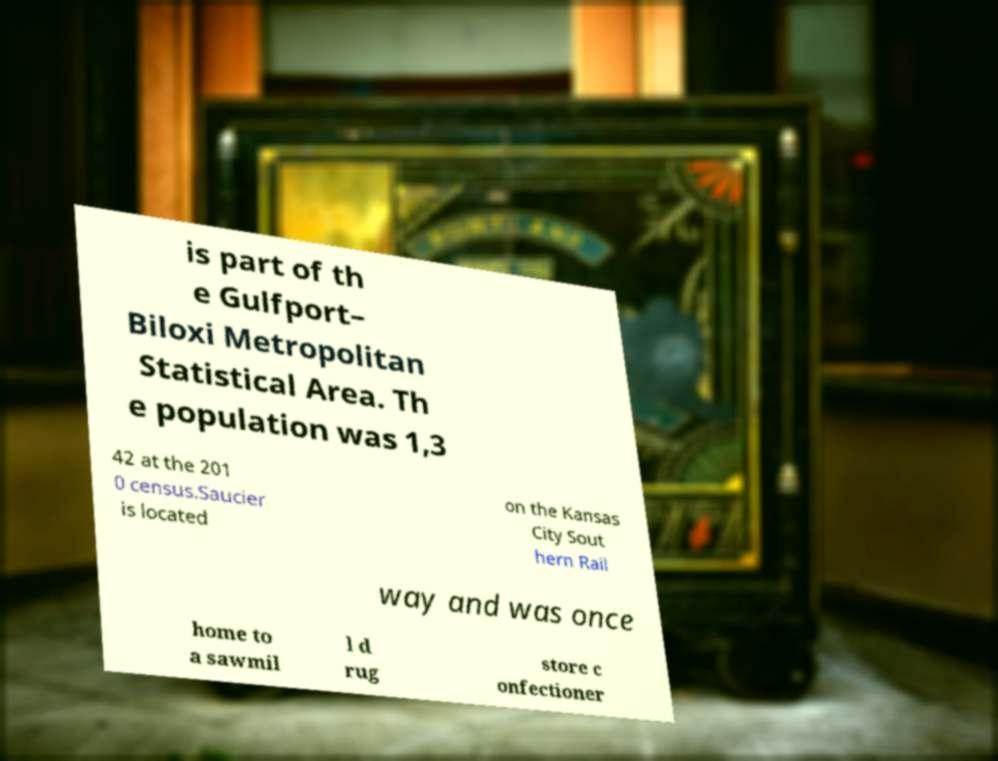I need the written content from this picture converted into text. Can you do that? is part of th e Gulfport– Biloxi Metropolitan Statistical Area. Th e population was 1,3 42 at the 201 0 census.Saucier is located on the Kansas City Sout hern Rail way and was once home to a sawmil l d rug store c onfectioner 